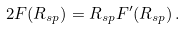<formula> <loc_0><loc_0><loc_500><loc_500>2 F ( R _ { s p } ) = R _ { s p } F ^ { \prime } ( R _ { s p } ) \, .</formula> 